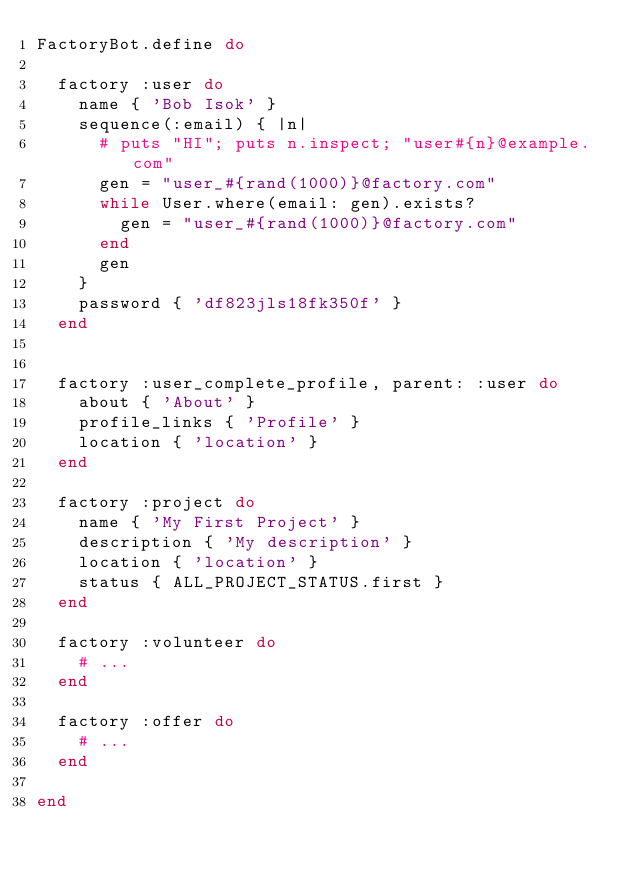<code> <loc_0><loc_0><loc_500><loc_500><_Ruby_>FactoryBot.define do

  factory :user do
    name { 'Bob Isok' }
    sequence(:email) { |n|
      # puts "HI"; puts n.inspect; "user#{n}@example.com"
      gen = "user_#{rand(1000)}@factory.com"
      while User.where(email: gen).exists?
        gen = "user_#{rand(1000)}@factory.com"
      end
      gen
    }
    password { 'df823jls18fk350f' }
  end


  factory :user_complete_profile, parent: :user do
    about { 'About' }
    profile_links { 'Profile' }
    location { 'location' }
  end

	factory :project do
    name { 'My First Project' }
    description { 'My description' }
    location { 'location' }
    status { ALL_PROJECT_STATUS.first }
  end

	factory :volunteer do
		# ...
	end

	factory :offer do
		# ...
	end

end</code> 